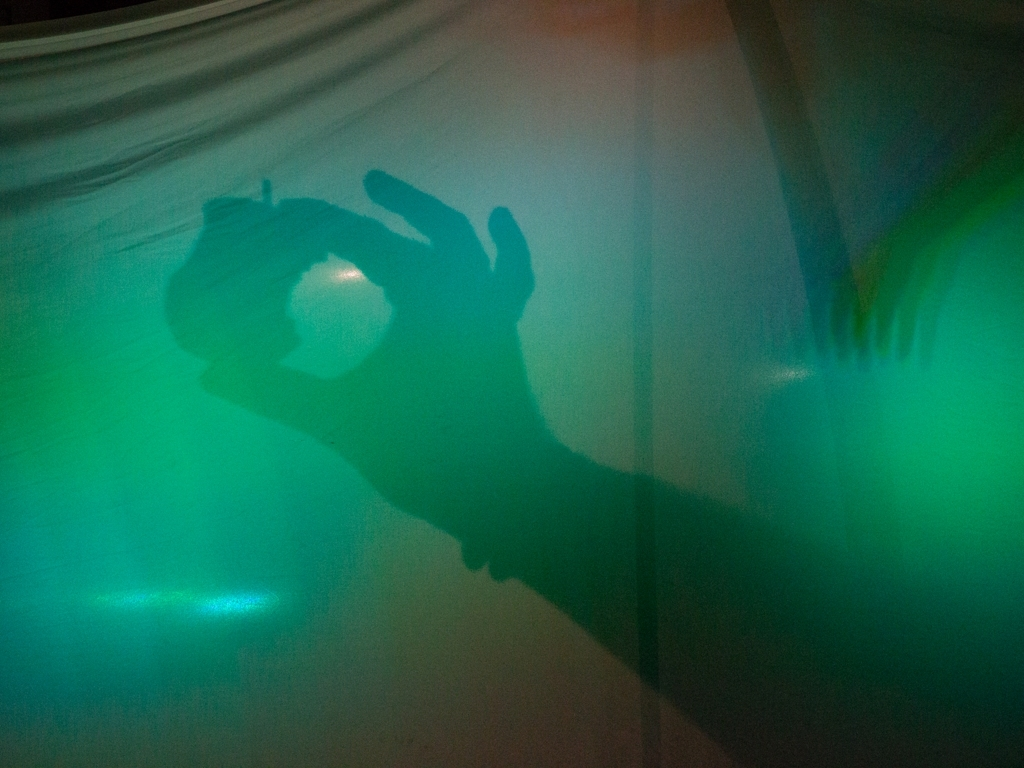Is there any noise in this image?
A. No noise at all
B. Very little noise
C. The noise is minimal
D. Yes, there is a significant amount of noise. Upon examining the image, one can observe subtle variations in light and a hint of grain that could be perceived as minimal noise. Therefore, a more accurate choice would be 'C. The noise is minimal.' This captures the light grain present without overstating its impact on the image's overall visual quality. 